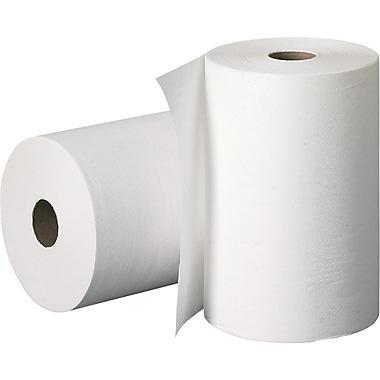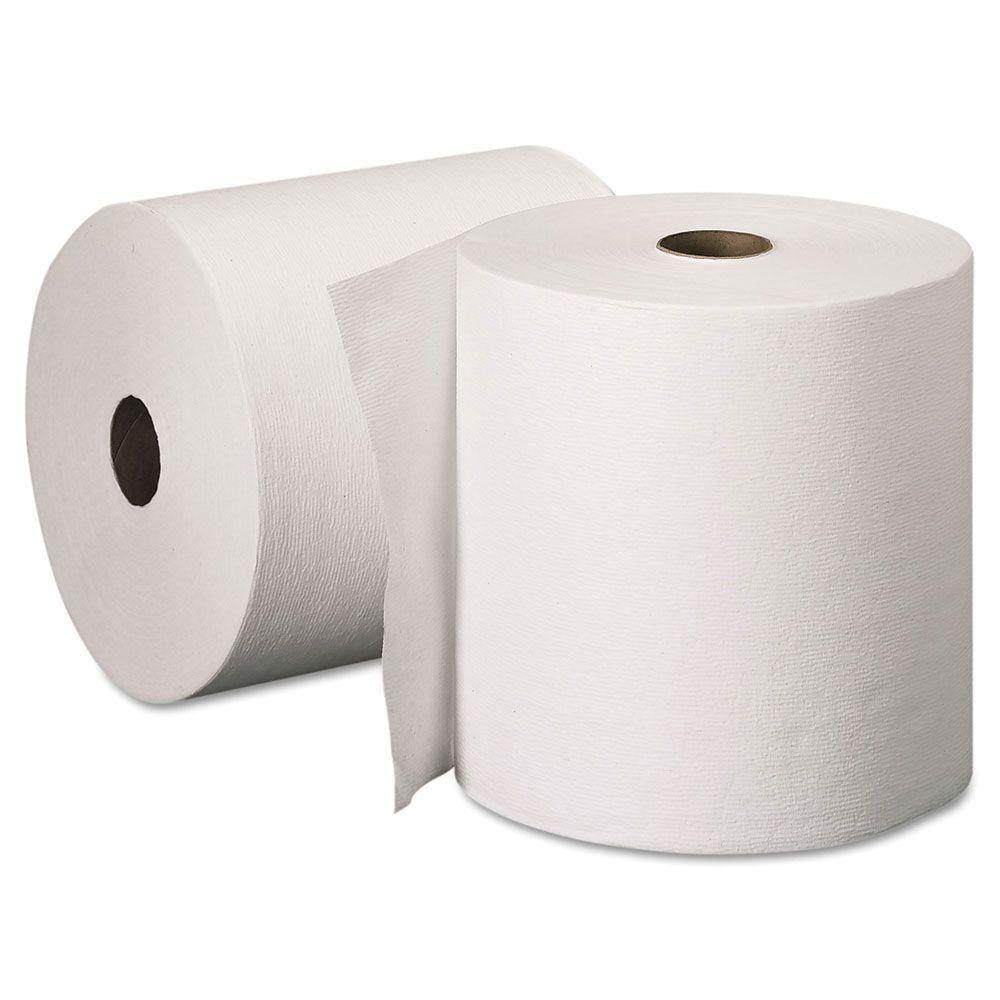The first image is the image on the left, the second image is the image on the right. For the images shown, is this caption "All these images contain paper towels standing upright on their rolls." true? Answer yes or no. Yes. 